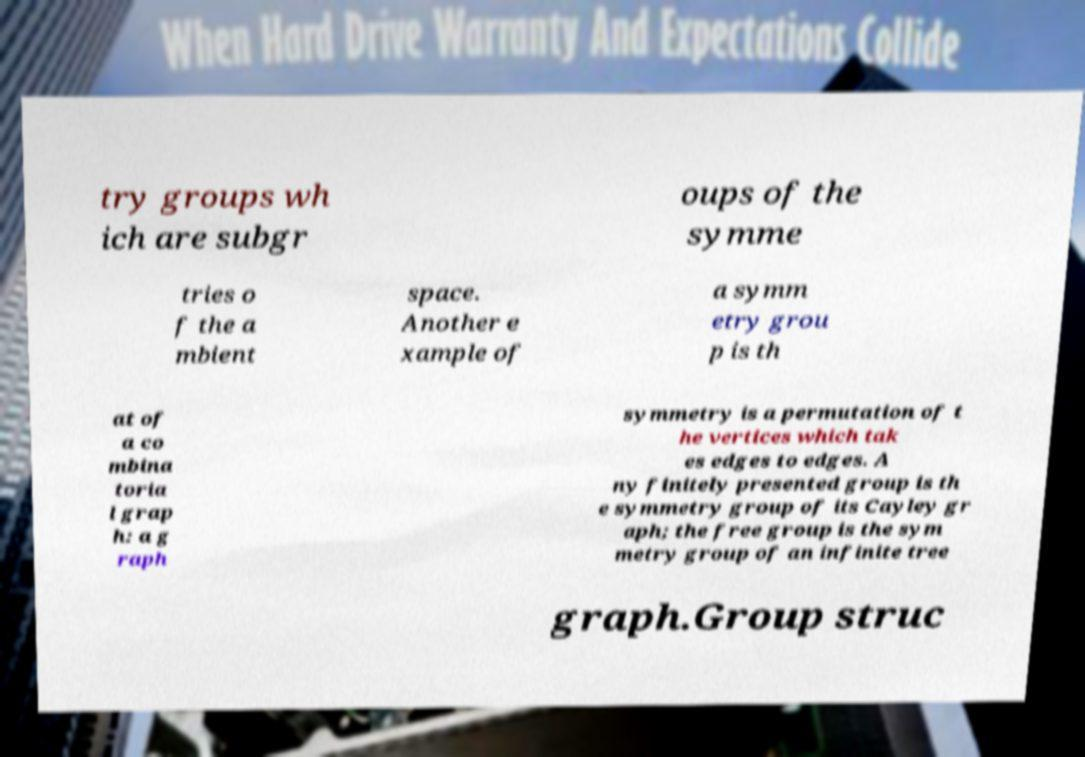Can you accurately transcribe the text from the provided image for me? try groups wh ich are subgr oups of the symme tries o f the a mbient space. Another e xample of a symm etry grou p is th at of a co mbina toria l grap h: a g raph symmetry is a permutation of t he vertices which tak es edges to edges. A ny finitely presented group is th e symmetry group of its Cayley gr aph; the free group is the sym metry group of an infinite tree graph.Group struc 